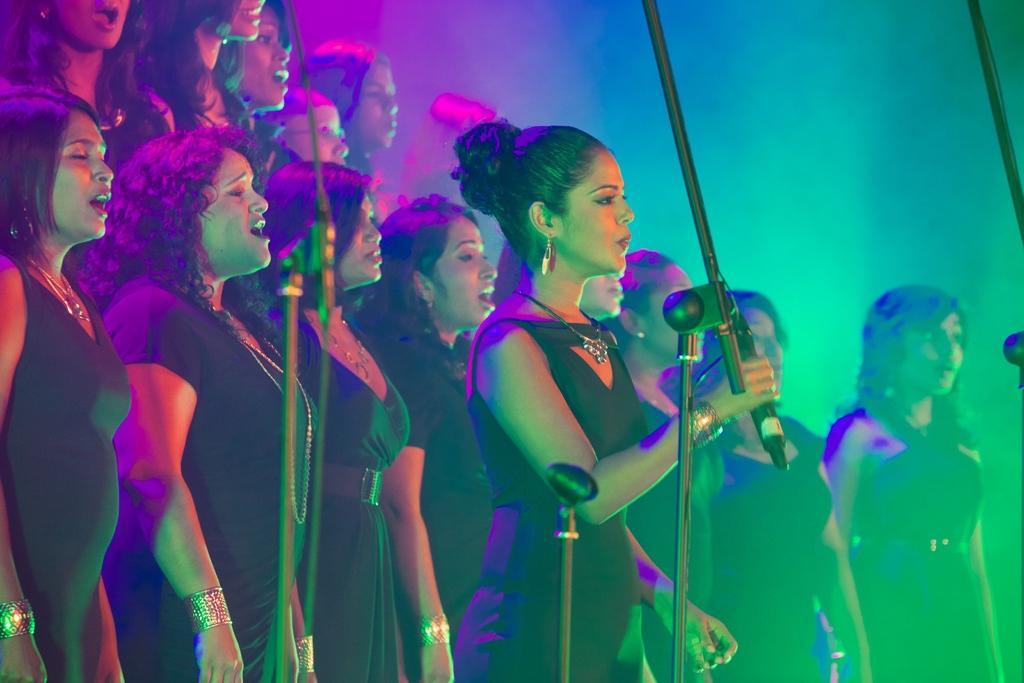Please provide a concise description of this image. In this image I can see group of girls and in front them I can see miles and in the background I can see light focus and a girl holding a mike in the foreground. 